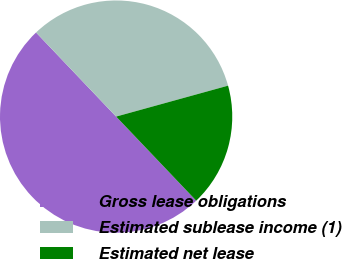Convert chart to OTSL. <chart><loc_0><loc_0><loc_500><loc_500><pie_chart><fcel>Gross lease obligations<fcel>Estimated sublease income (1)<fcel>Estimated net lease<nl><fcel>50.0%<fcel>32.82%<fcel>17.18%<nl></chart> 